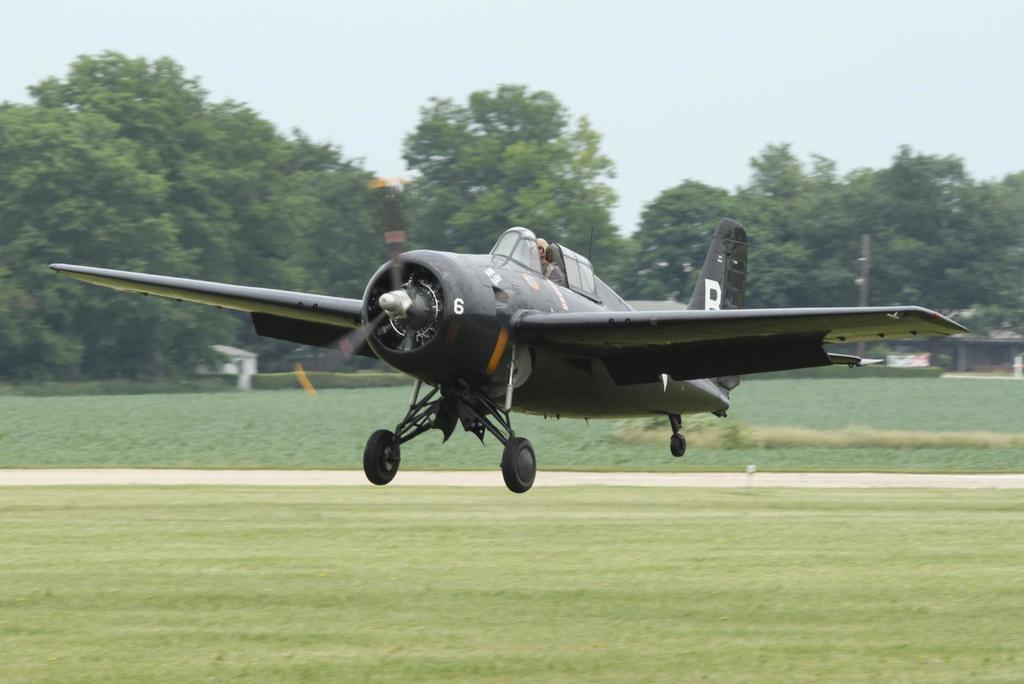How would you summarize this image in a sentence or two? In this image we can see an airplane, few trees, grass, building and the sky in the background. 